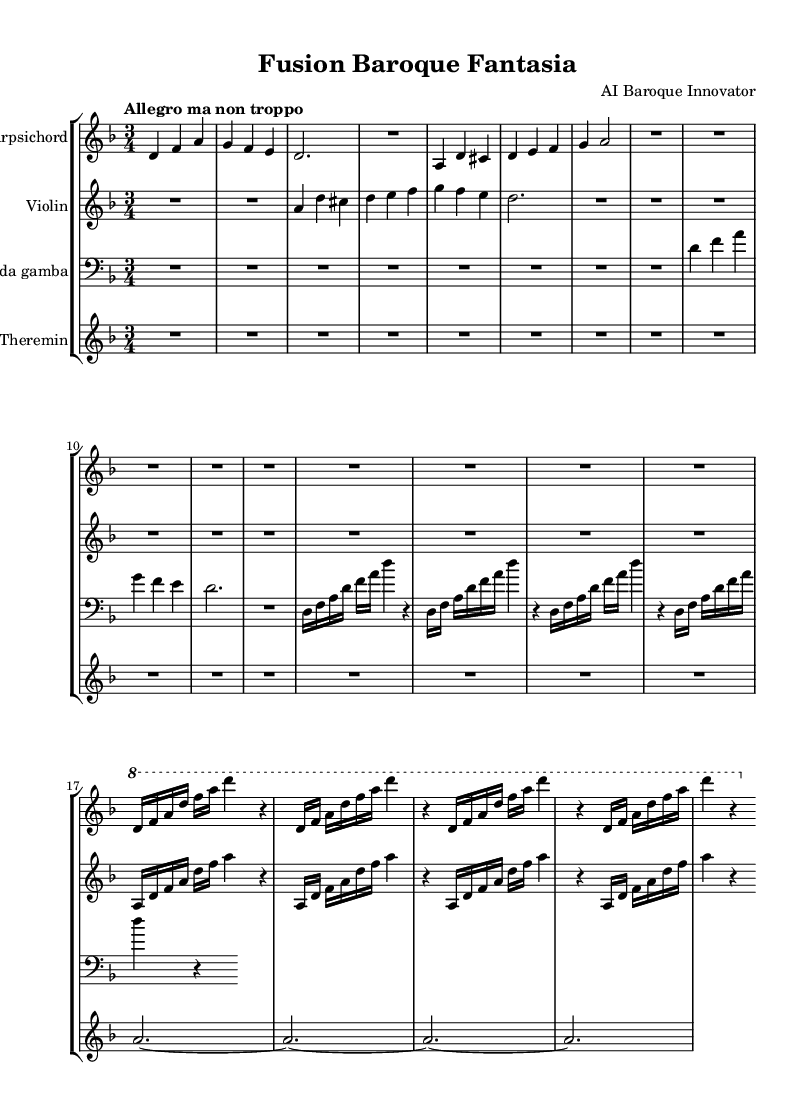what is the key signature of this music? The key signature is indicated at the beginning of the score, showing two flats, which corresponds to D minor.
Answer: D minor what is the time signature of this music? The time signature is found at the beginning of the score, indicated by a "3/4" notation, meaning there are three beats per measure and the quarter note gets one beat.
Answer: 3/4 what is the tempo marking of this music? The tempo marking is specified in the score as "Allegro ma non troppo," which means lively but not too fast.
Answer: Allegro ma non troppo how many measures are there in total for the Harpsichord part? Counting the measures for the Harpsichord part, there are 16 individual measures notated, beginning with the first measure and ending with the final measures indicated.
Answer: 16 what instruments are featured in this chamber music? The score lists the specific instruments used, which are Harpsichord, Violin, Viola da gamba, and Theremin.
Answer: Harpsichord, Violin, Viola da gamba, Theremin which part starts with a rest? The Violin part begins with a rest as indicated in the first few measures, showing the sections of silence before the music begins to play.
Answer: Violin how many times is the motif repeated in the Viola da gamba part? The motif in the Viola da gamba part is repeated four times as seen in the measures where a similar rhythmic and melodic figure occurs consistently.
Answer: 4 